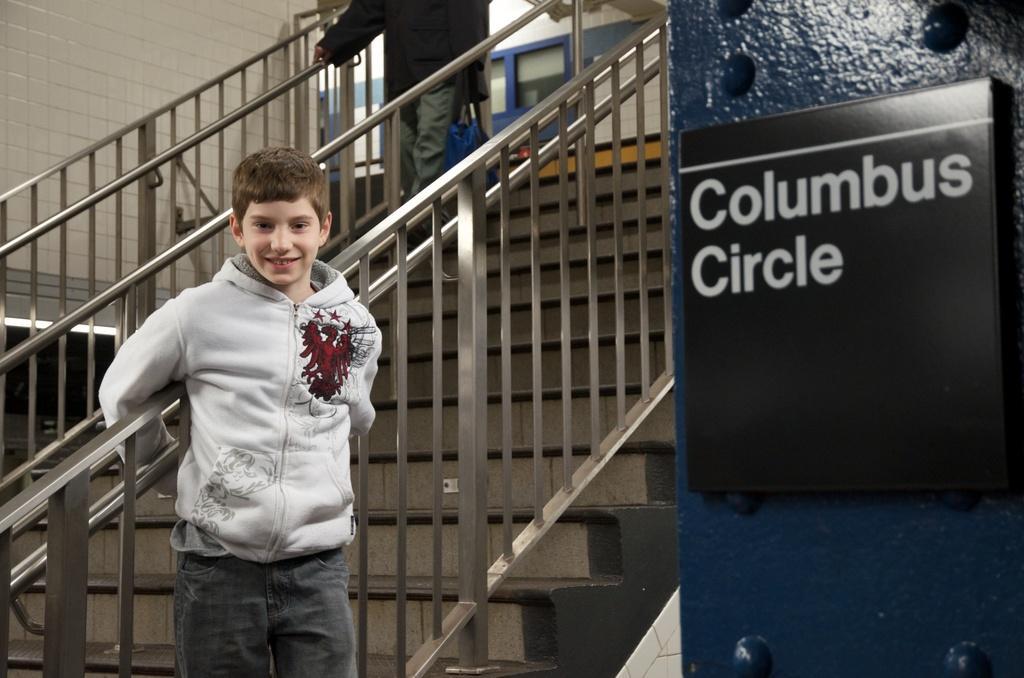How would you summarize this image in a sentence or two? In the background we can see the wall, railings, stairs and a person. On the right side of the picture we can see a board on the pillar. In this picture we can see a boy wearing a jacket and he is smiling. 